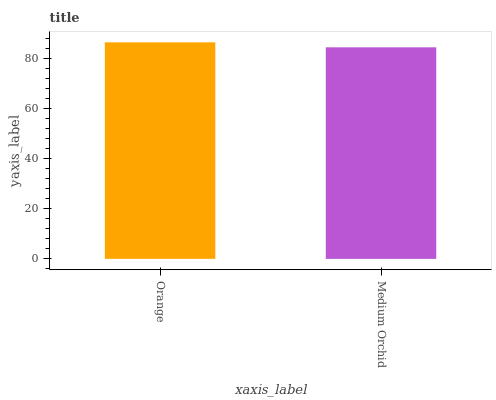Is Medium Orchid the minimum?
Answer yes or no. Yes. Is Orange the maximum?
Answer yes or no. Yes. Is Medium Orchid the maximum?
Answer yes or no. No. Is Orange greater than Medium Orchid?
Answer yes or no. Yes. Is Medium Orchid less than Orange?
Answer yes or no. Yes. Is Medium Orchid greater than Orange?
Answer yes or no. No. Is Orange less than Medium Orchid?
Answer yes or no. No. Is Orange the high median?
Answer yes or no. Yes. Is Medium Orchid the low median?
Answer yes or no. Yes. Is Medium Orchid the high median?
Answer yes or no. No. Is Orange the low median?
Answer yes or no. No. 